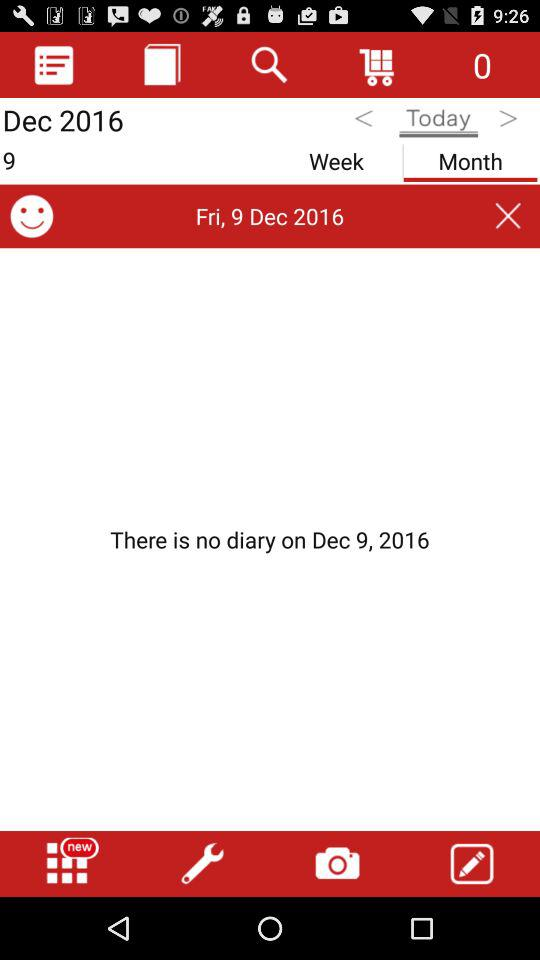What is the given date? The given date is Friday, December 9, 2016. 